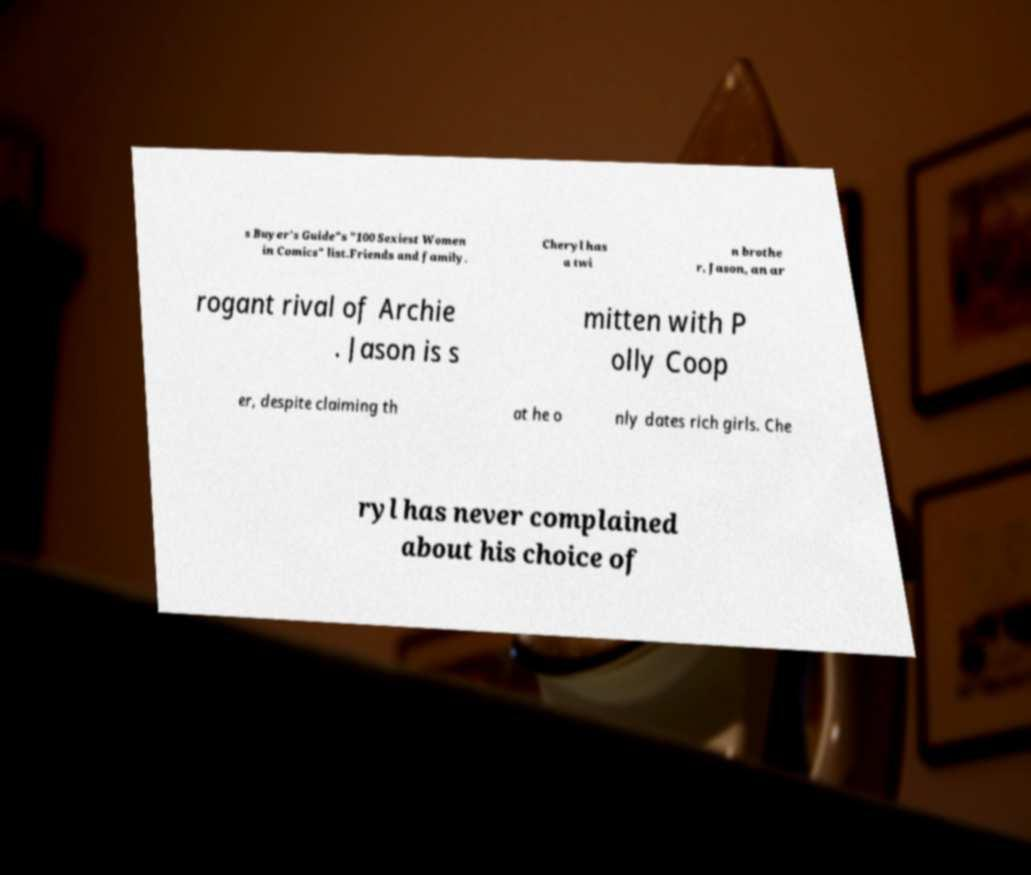Can you accurately transcribe the text from the provided image for me? s Buyer's Guide"s "100 Sexiest Women in Comics" list.Friends and family. Cheryl has a twi n brothe r, Jason, an ar rogant rival of Archie . Jason is s mitten with P olly Coop er, despite claiming th at he o nly dates rich girls. Che ryl has never complained about his choice of 